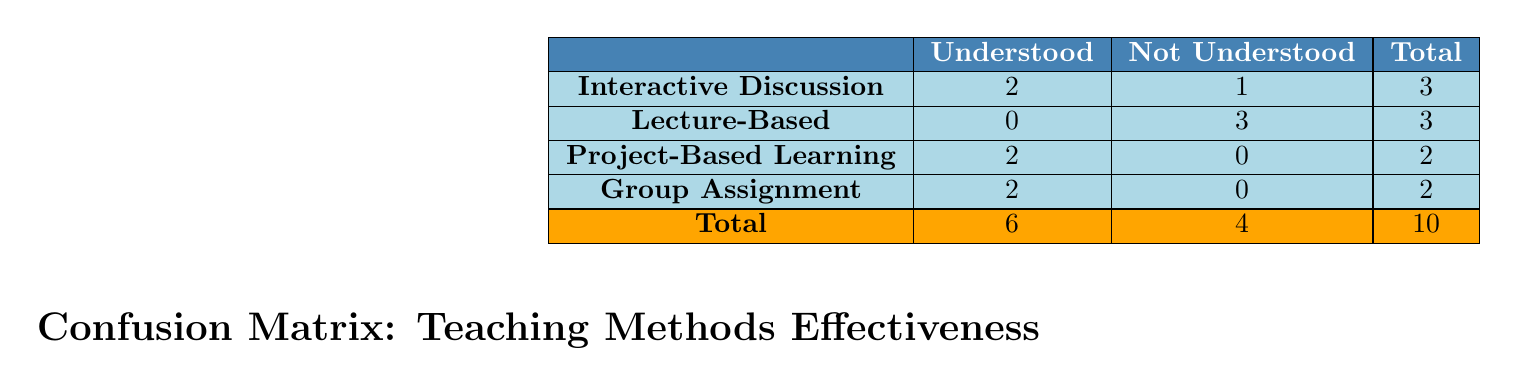What is the total number of students who understood the significance of local heroes? By looking at the "Understood" column, we can see that 2 students from Interactive Discussion, 2 students from Project-Based Learning, and 2 students from Group Assignment understood the significance. Summing these gives us 2 + 2 + 2 = 6 students.
Answer: 6 How many students did not understand the significance when taught through the Lecture-Based method? Referring to the Lecture-Based row, the "Not Understood" column indicates that 3 students did not understand the significance.
Answer: 3 What teaching method had the highest number of students who understood the significance? Checking the "Understood" column across methods, Interactive Discussion, Project-Based Learning, and Group Assignment each have 2 students, but Lecture-Based has 0. Since the highest values are tied, we can say that Interactive Discussion, Project-Based Learning, and Group Assignment all had the same highest number of 2 students.
Answer: Interactive Discussion, Project-Based Learning, and Group Assignment How many students in total were evaluated under the Group Assignment method? The total for Group Assignment in the "Total" column is 2 students, as seen in the row for Group Assignment.
Answer: 2 Is it true that all students who used Project-Based Learning understood the significance? Looking at the Project-Based Learning row, the "Not Understood" column shows 0, indicating that all students under this method understood the significance. Therefore, the statement is true.
Answer: Yes What is the total number of students who did not understand any teaching method? To find the total of students who did not understand the significance, we need to look at the "Not Understood" column across all methods. Adding those values gives us 1 (Interactive Discussion) + 3 (Lecture-Based) + 0 (Project-Based Learning) + 0 (Group Assignment) = 4 students.
Answer: 4 Which teaching method had a 100% success rate in helping students understand the significance of local heroes? We analyze each row to find a method where all students understood the significance (i.e., the count in "Not Understood" is 0). Project-Based Learning and Group Assignment both have 0 in that column, meaning they had a 100% success rate.
Answer: Project-Based Learning and Group Assignment What was the ratio of students who understood to those who did not understand when using Interactive Discussion? The Interactive Discussion method had 2 students who understood and 1 who did not. The ratio can be found by calculating 2 (understood) to 1 (not understood), which simplifies to 2:1.
Answer: 2:1 